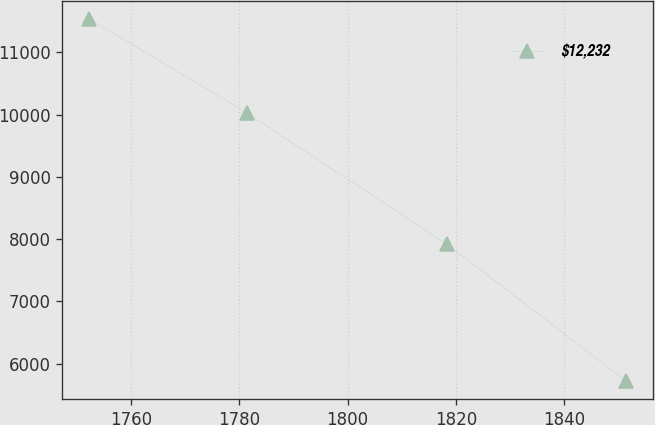Convert chart to OTSL. <chart><loc_0><loc_0><loc_500><loc_500><line_chart><ecel><fcel>$12,232<nl><fcel>1752.2<fcel>11538.3<nl><fcel>1781.47<fcel>10018.6<nl><fcel>1818.36<fcel>7917.29<nl><fcel>1851.48<fcel>5720.55<nl></chart> 